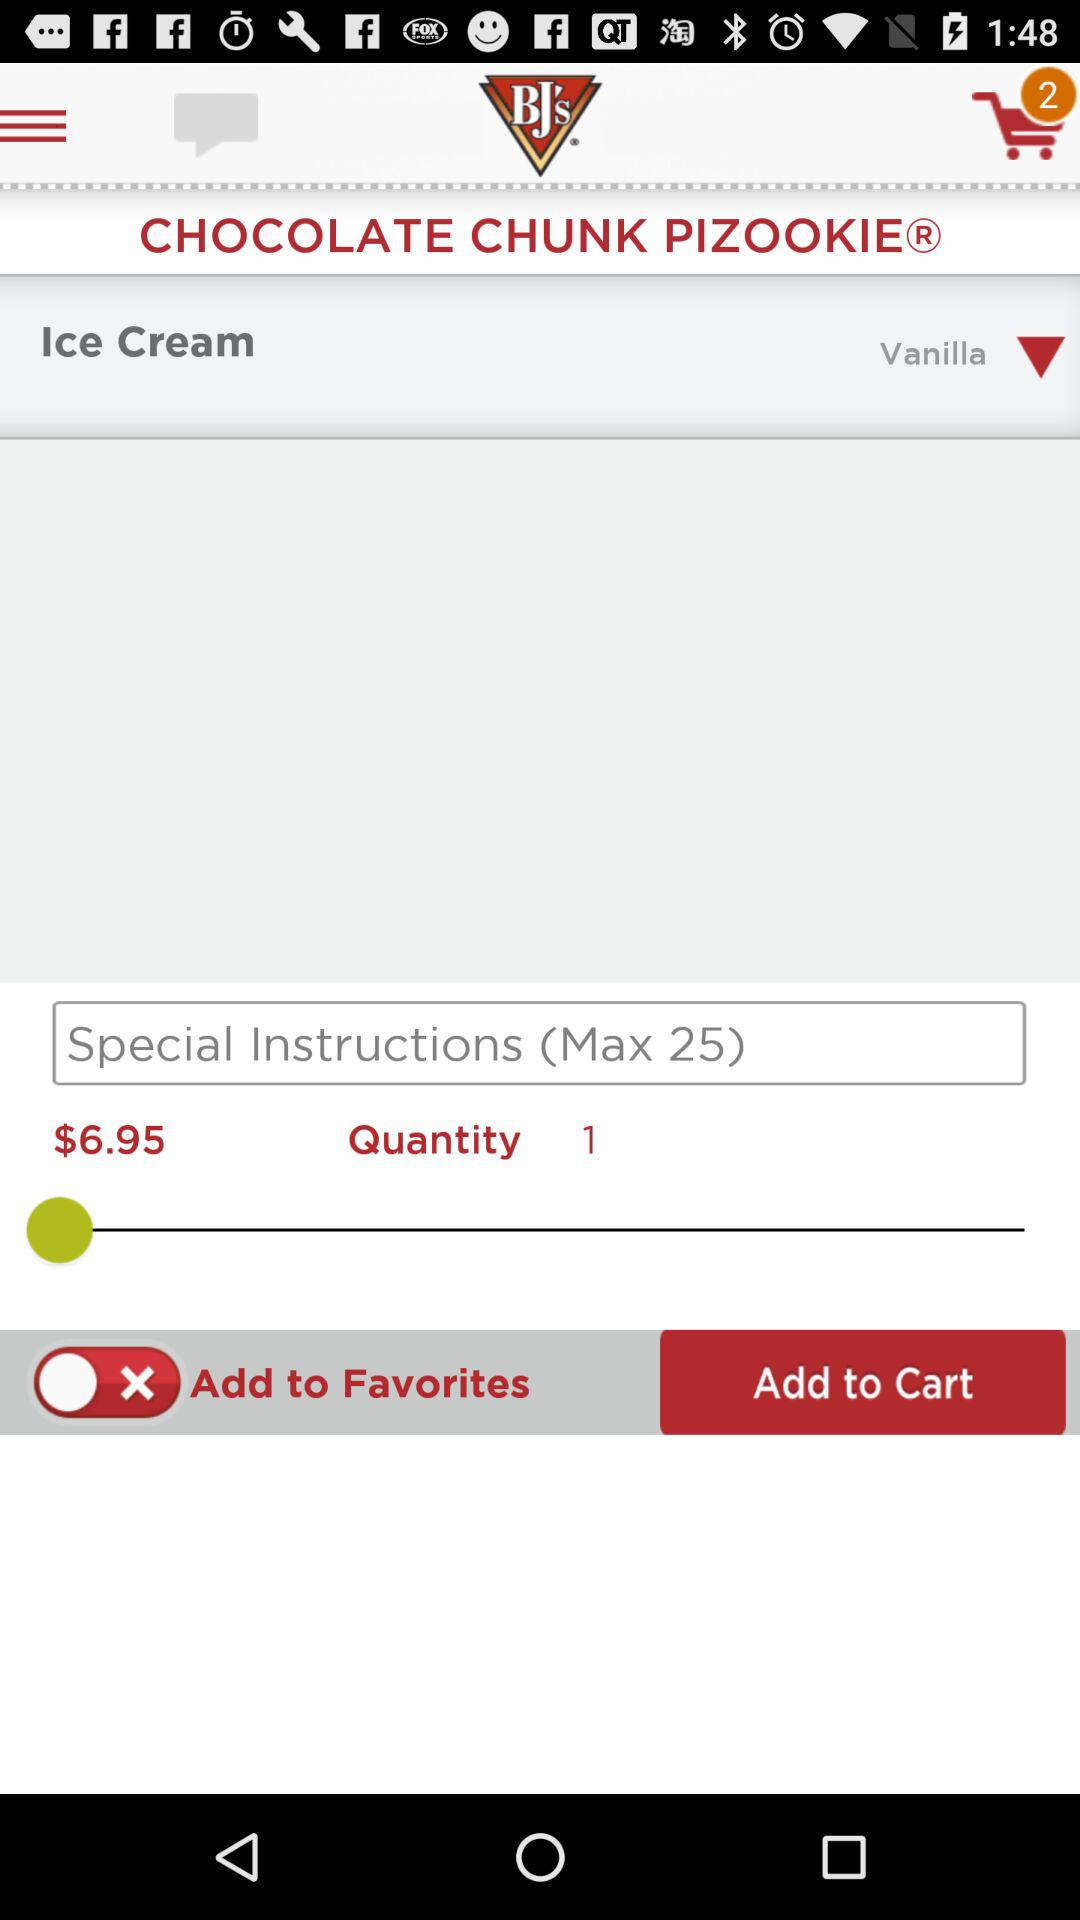What is the total quantity of the item? The total quantity of the item is 1. 